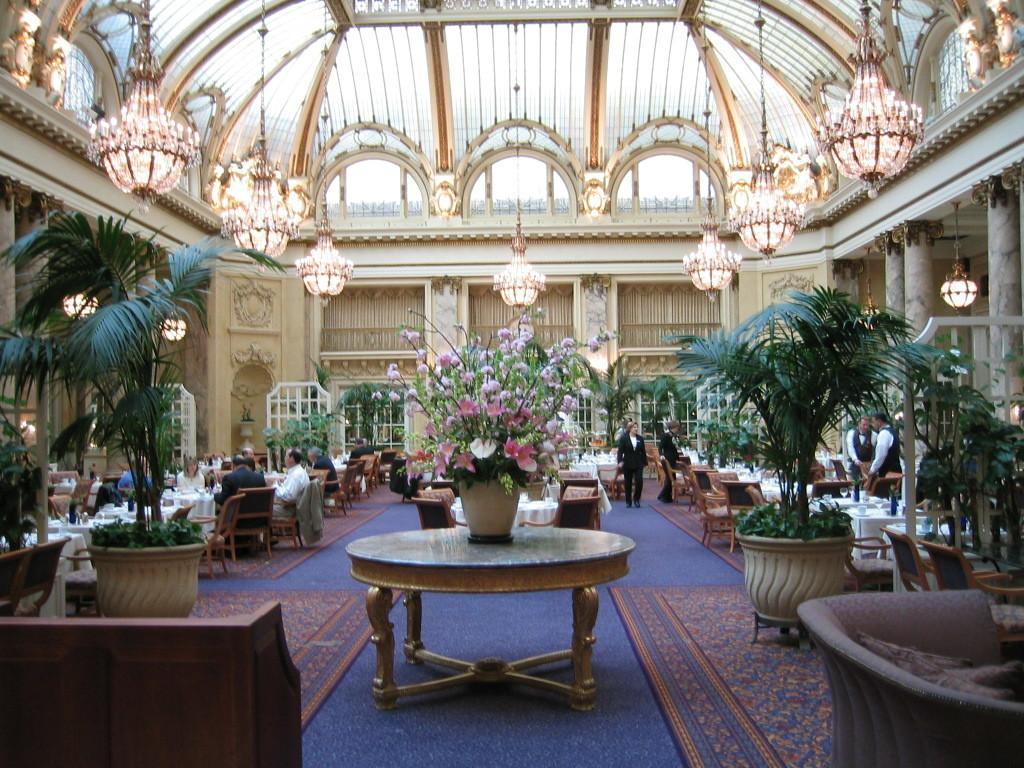How would you summarize this image in a sentence or two? In the middle of the picture, we see a table on which a flower pot is placed. Behind that, we see many chairs and tables. On the left side, we see the plant pots and beside that, we see the people are sitting on the chairs. In front of them, we see the tables. In the left bottom, we see a chair or a bench in brown color. In the right bottom, we see a sofa. On the right side, we see the plant pots, chairs and tables on which some objects are placed. We see the people are standing. In the background, we see a wall and the windows. At the top, we see the chandeliers and the roof of the building. 